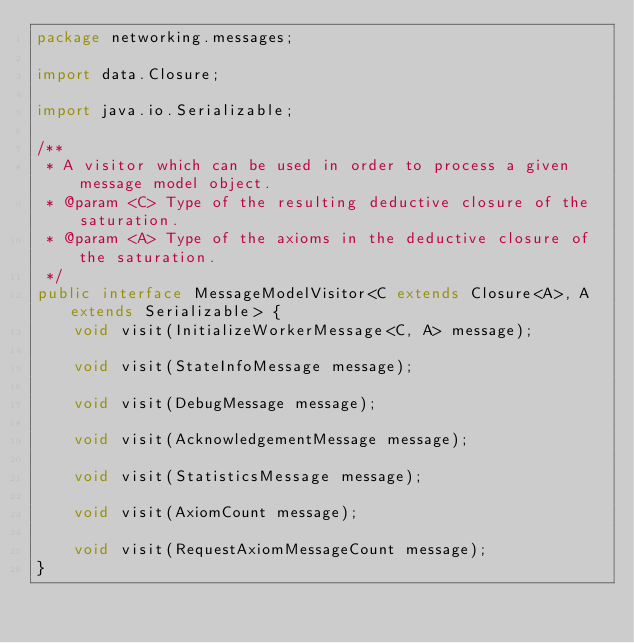Convert code to text. <code><loc_0><loc_0><loc_500><loc_500><_Java_>package networking.messages;

import data.Closure;

import java.io.Serializable;

/**
 * A visitor which can be used in order to process a given message model object.
 * @param <C> Type of the resulting deductive closure of the saturation.
 * @param <A> Type of the axioms in the deductive closure of the saturation.
 */
public interface MessageModelVisitor<C extends Closure<A>, A extends Serializable> {
    void visit(InitializeWorkerMessage<C, A> message);

    void visit(StateInfoMessage message);

    void visit(DebugMessage message);

    void visit(AcknowledgementMessage message);

    void visit(StatisticsMessage message);

    void visit(AxiomCount message);

    void visit(RequestAxiomMessageCount message);
}
</code> 